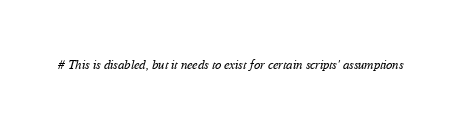<code> <loc_0><loc_0><loc_500><loc_500><_Python_># This is disabled, but it needs to exist for certain scripts' assumptions</code> 